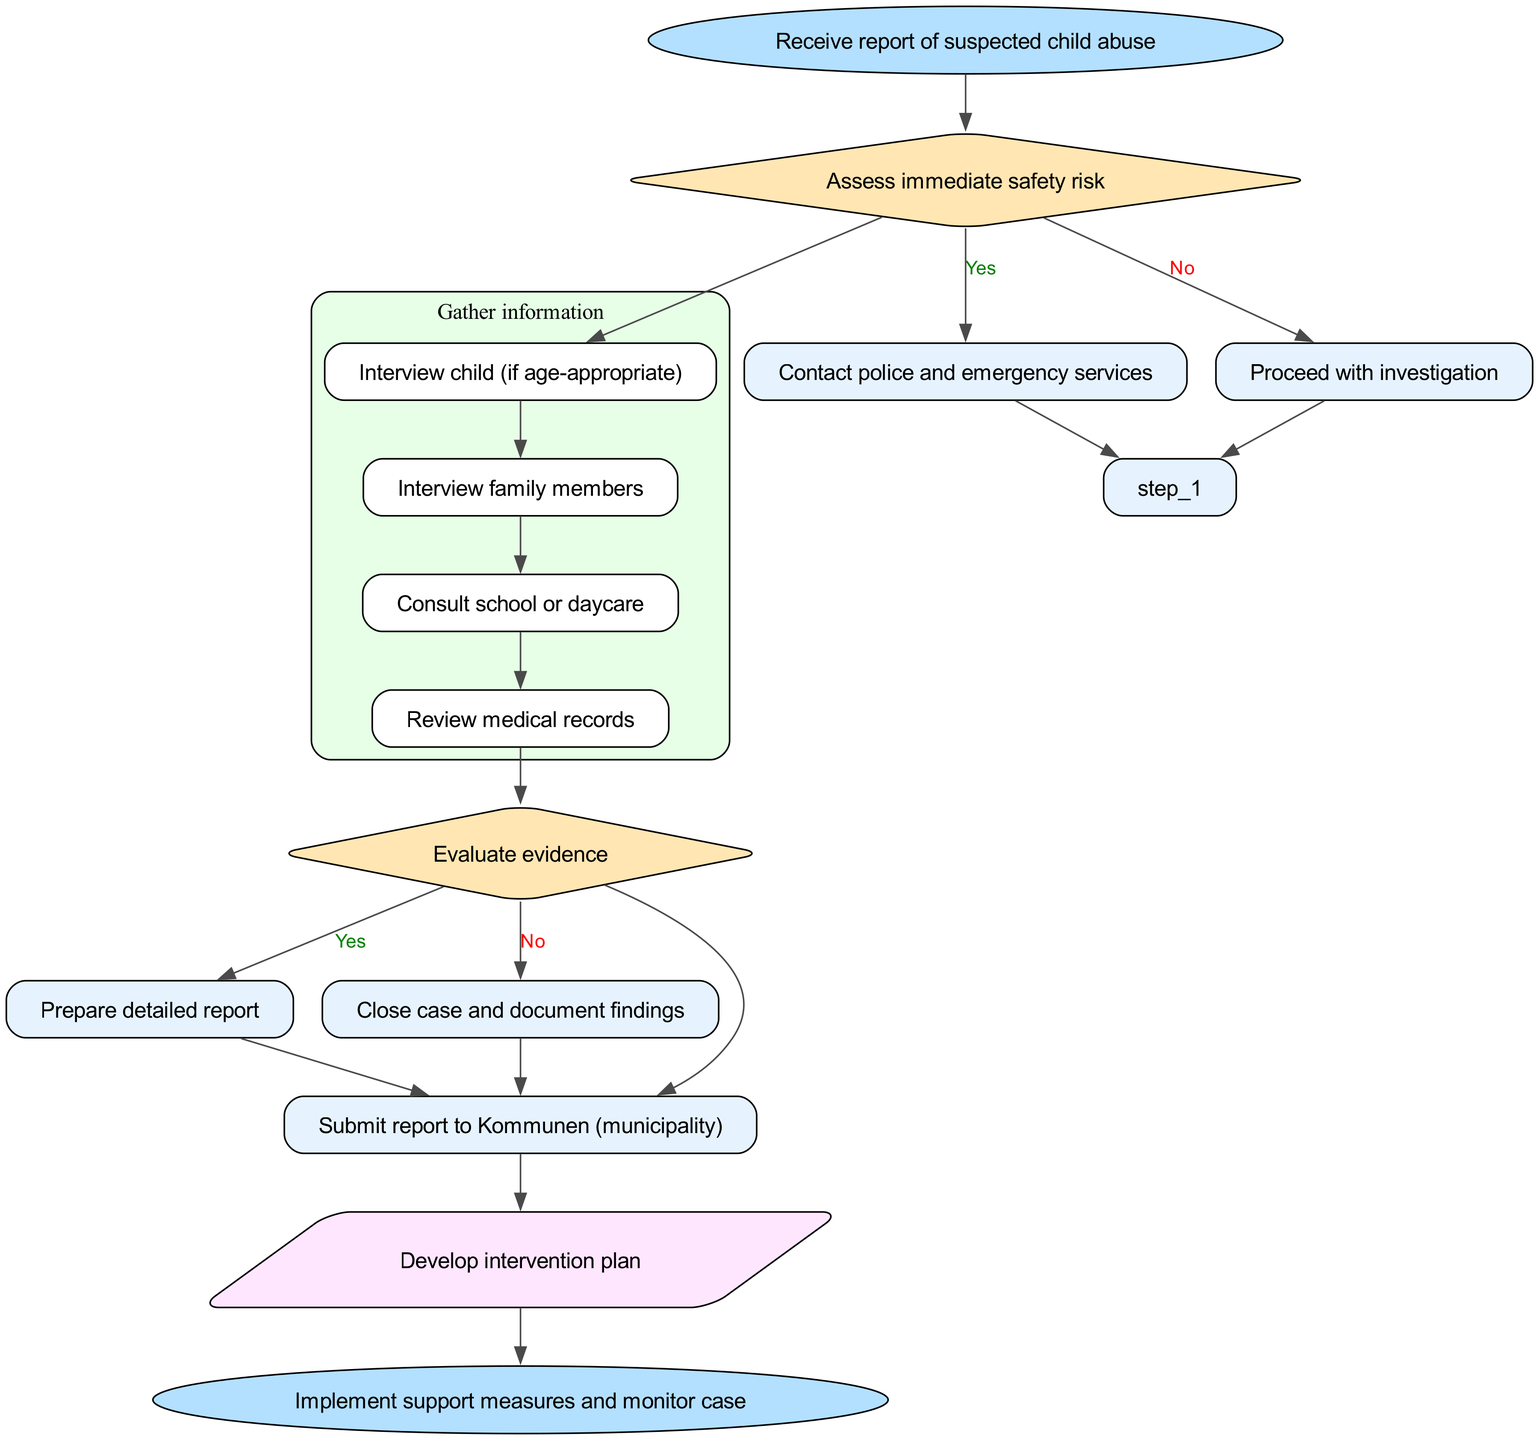What is the first action taken in the flow chart? The flow chart starts with the action "Receive report of suspected child abuse", which is represented as the first node leading to subsequent steps.
Answer: Receive report of suspected child abuse What decision is made after assessing immediate safety risk? After the action "Assess immediate safety risk", a decision node asks "Is child in immediate danger?". Depending on the answer, it leads to different subsequent actions.
Answer: Is child in immediate danger? How many tasks are included in the "Gather information" step? The "Gather information" step lists four tasks: interviewing the child, interviewing family members, consulting the school or daycare, and reviewing medical records, which gives a total of four tasks.
Answer: 4 What happens if the abuse is substantiated? If it is concluded that the abuse is substantiated, the flow chart indicates that the next action is "Prepare detailed report", leading toward formal documentation of the case findings.
Answer: Prepare detailed report What follow-up action is identified after submitting the report to Kommunen? After the step of submitting the report to Kommunen, the diagram specifies a follow-up action called "Develop intervention plan", which is crucial in planning the next steps for the child's well-being.
Answer: Develop intervention plan What is the endpoint of the flow chart? The final node in the flow chart is labeled "Implement support measures and monitor case", indicating the conclusion of the assessment and the initiation of support mechanisms for the child.
Answer: Implement support measures and monitor case What action should be taken if the child is in immediate danger? If the assessment determines that the child is in immediate danger, the flow chart directs to "Contact police and emergency services" to ensure the child's safety as a priority action.
Answer: Contact police and emergency services What connects the "Assess immediate safety risk" step to the next node? The decision from "Assess immediate safety risk" connects to two paths based on the answer to "Is child in immediate danger?", leading to either contacting police or proceeding with the investigation.
Answer: Yes/No paths What is the nature of the node that asks "Is abuse substantiated?" The node asking "Is abuse substantiated?" is a decision node, represented in a diamond shape in the flow chart, indicating a point where a binary decision affects the flow of action.
Answer: Decision node 